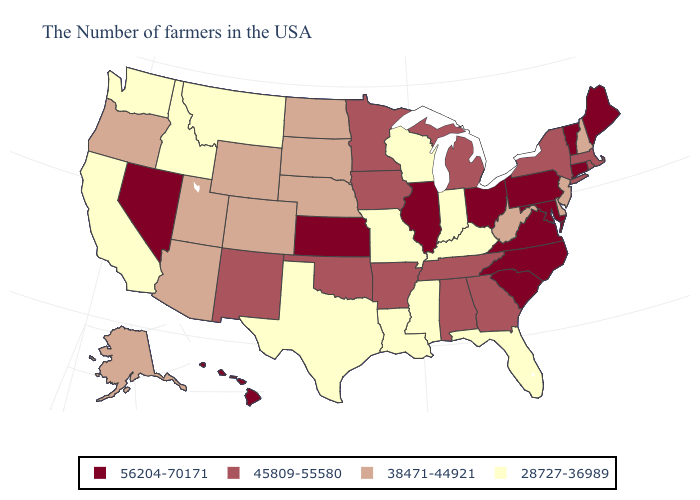Among the states that border New Mexico , does Arizona have the lowest value?
Keep it brief. No. Name the states that have a value in the range 45809-55580?
Write a very short answer. Massachusetts, Rhode Island, New York, Georgia, Michigan, Alabama, Tennessee, Arkansas, Minnesota, Iowa, Oklahoma, New Mexico. Does Idaho have the highest value in the West?
Answer briefly. No. Which states have the lowest value in the South?
Be succinct. Florida, Kentucky, Mississippi, Louisiana, Texas. Does Oregon have a lower value than Mississippi?
Be succinct. No. Is the legend a continuous bar?
Answer briefly. No. What is the value of Vermont?
Write a very short answer. 56204-70171. Name the states that have a value in the range 38471-44921?
Concise answer only. New Hampshire, New Jersey, Delaware, West Virginia, Nebraska, South Dakota, North Dakota, Wyoming, Colorado, Utah, Arizona, Oregon, Alaska. Name the states that have a value in the range 28727-36989?
Short answer required. Florida, Kentucky, Indiana, Wisconsin, Mississippi, Louisiana, Missouri, Texas, Montana, Idaho, California, Washington. How many symbols are there in the legend?
Be succinct. 4. Which states hav the highest value in the West?
Be succinct. Nevada, Hawaii. Among the states that border Nevada , which have the lowest value?
Concise answer only. Idaho, California. Among the states that border South Carolina , does North Carolina have the lowest value?
Give a very brief answer. No. What is the value of Texas?
Write a very short answer. 28727-36989. Name the states that have a value in the range 38471-44921?
Quick response, please. New Hampshire, New Jersey, Delaware, West Virginia, Nebraska, South Dakota, North Dakota, Wyoming, Colorado, Utah, Arizona, Oregon, Alaska. 